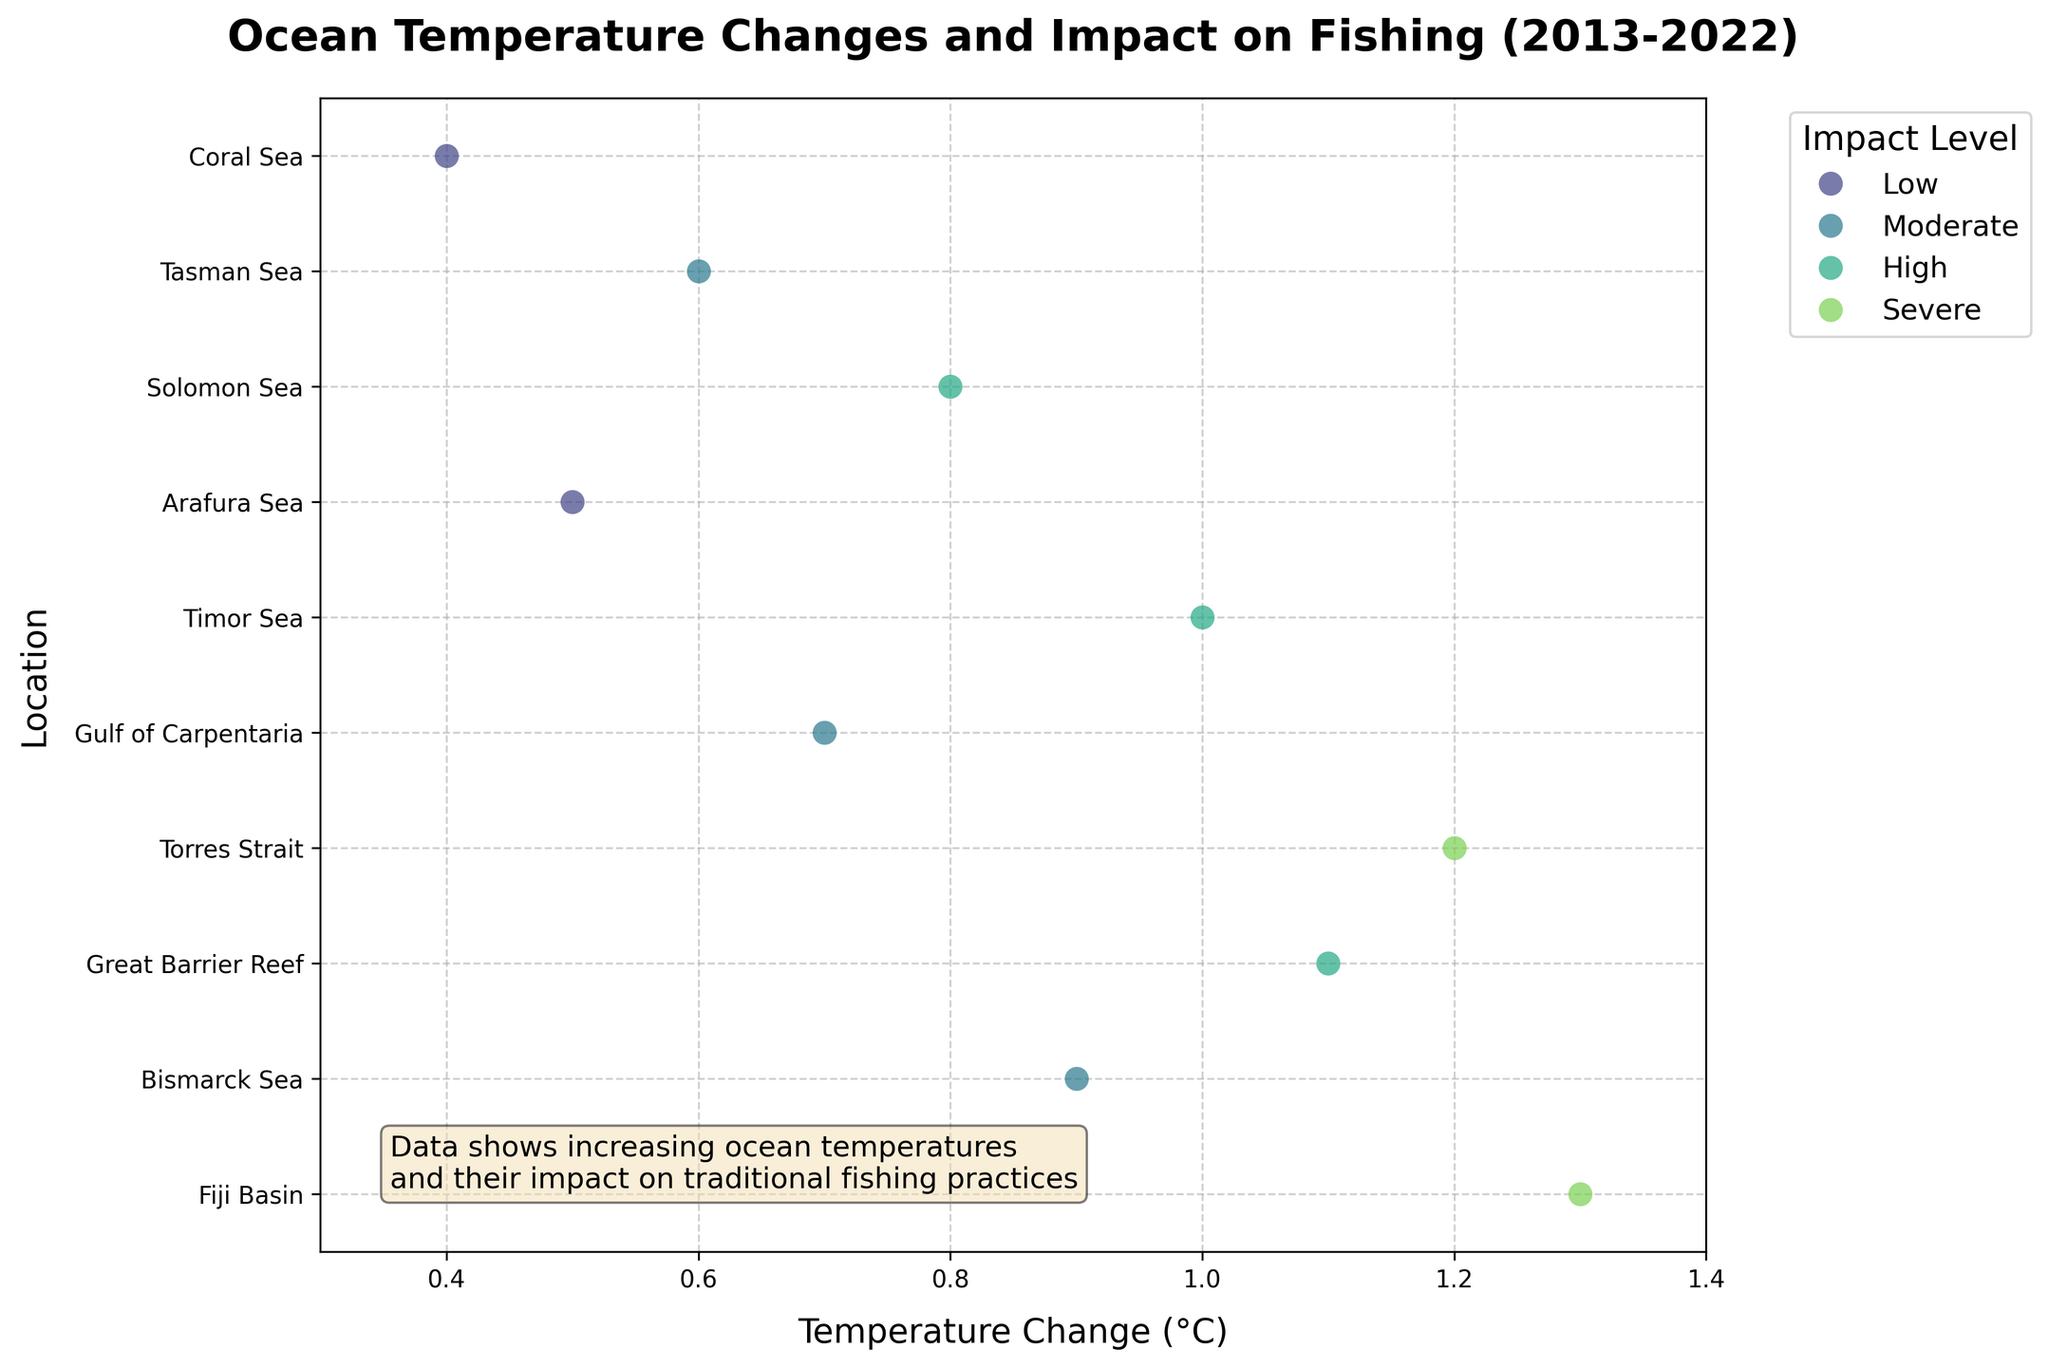Which location had the highest temperature change? To determine the location with the highest temperature change, look for the highest value on the x-axis. According to the figure, the highest temperature change (1.3°C) occurred in the Fiji Basin.
Answer: Fiji Basin How many locations experienced a 'Severe' impact level due to temperature change? Count the number of data points marked with the color corresponding to 'Severe' in the legend. In the figure, there are two 'Severe' impact levels: Torres Strait and Fiji Basin.
Answer: 2 What is the average temperature change for the locations with 'High' impact level? Identify the temperature changes for locations with 'High' impact level: Timor Sea (1.0°C), Great Barrier Reef (1.1°C). Sum these values and divide by the number of points (2). (1.0 + 1.1) / 2 = 1.05°C.
Answer: 1.05°C Which location had the lowest temperature change and what was the impact level there? Locate the data point with the smallest x-axis value. In the figure, the lowest temperature change (0.4°C) was in the Coral Sea, and the impact level there is 'Low'.
Answer: Coral Sea, Low Compare the temperature change of the Great Barrier Reef and Coral Sea; which one is higher and by how much? The temperature change for the Great Barrier Reef is 1.1°C, and for the Coral Sea is 0.4°C. Subtract the smaller value from the larger one: 1.1 - 0.4 = 0.7°C. The Great Barrier Reef has a higher temperature change by 0.7°C.
Answer: Great Barrier Reef, 0.7°C Which impact level is most frequently observed across all locations? Evaluate the number of occurrences for each impact level by looking at the color-coded points in the figure. Moderate is seen thrice (Tasman Sea, Gulf of Carpentaria, Bismarck Sea).
Answer: Moderate What was the temperature change in the Gulf of Carpentaria, and how does it compare to that in the Tasman Sea? Identify the values on the x-axis for Gulf of Carpentaria and Tasman Sea; Gulf of Carpentaria is 0.7°C, and Tasman Sea is 0.6°C. The temperature change is 0.1°C higher in the Gulf of Carpentaria.
Answer: 0.7°C, Gulf of Carpentaria is higher by 0.1°C Which fish species were impacted in the locations with the highest and lowest temperature changes? Identify the fish species corresponding to the highest (Fiji Basin: Grouper) and lowest (Coral Sea: Yellowfin Tuna) temperature changes.
Answer: Grouper, Yellowfin Tuna How many locations experienced temperature changes of 1°C or higher? Count the number of data points that are positioned at 1°C or higher on the x-axis. These data points are found in the Timor Sea (1.0°C), Torres Strait (1.2°C), Great Barrier Reef (1.1°C), and Fiji Basin (1.3°C).
Answer: 4 